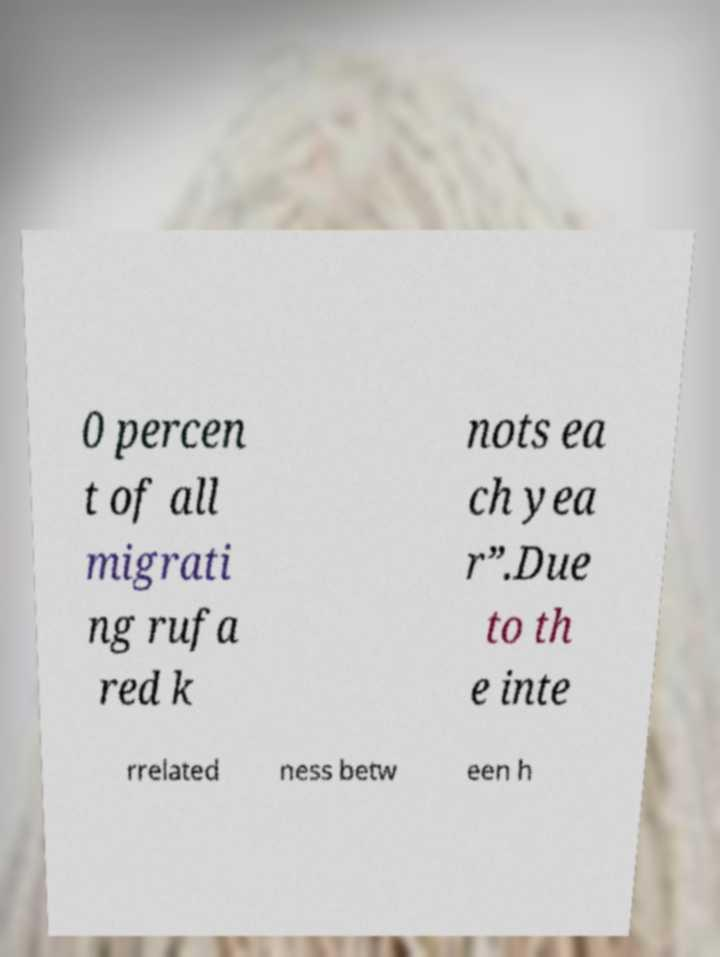For documentation purposes, I need the text within this image transcribed. Could you provide that? 0 percen t of all migrati ng rufa red k nots ea ch yea r”.Due to th e inte rrelated ness betw een h 